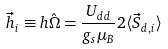Convert formula to latex. <formula><loc_0><loc_0><loc_500><loc_500>\vec { h } _ { i } \equiv h \hat { \Omega } = \frac { U _ { d d } } { g _ { s } \mu _ { B } } 2 \langle \vec { S } _ { d , i } \rangle</formula> 